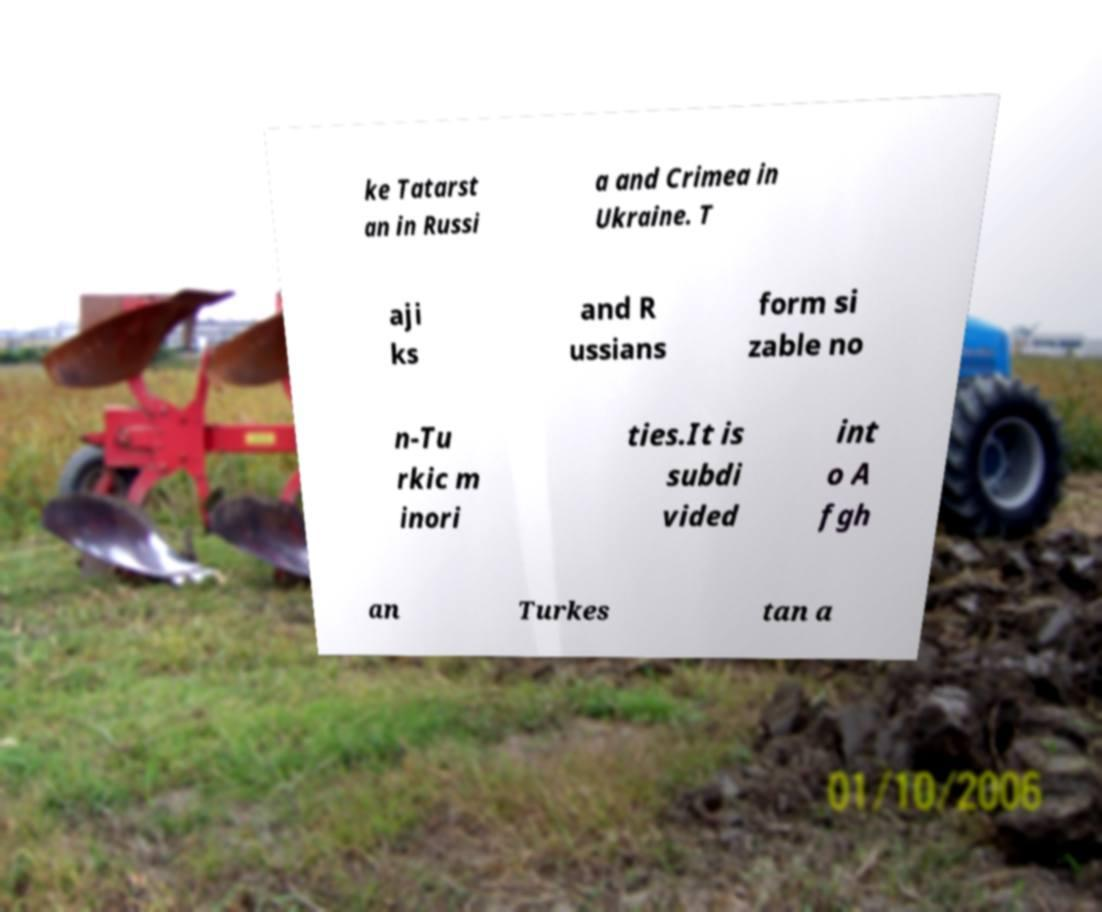Please read and relay the text visible in this image. What does it say? ke Tatarst an in Russi a and Crimea in Ukraine. T aji ks and R ussians form si zable no n-Tu rkic m inori ties.It is subdi vided int o A fgh an Turkes tan a 